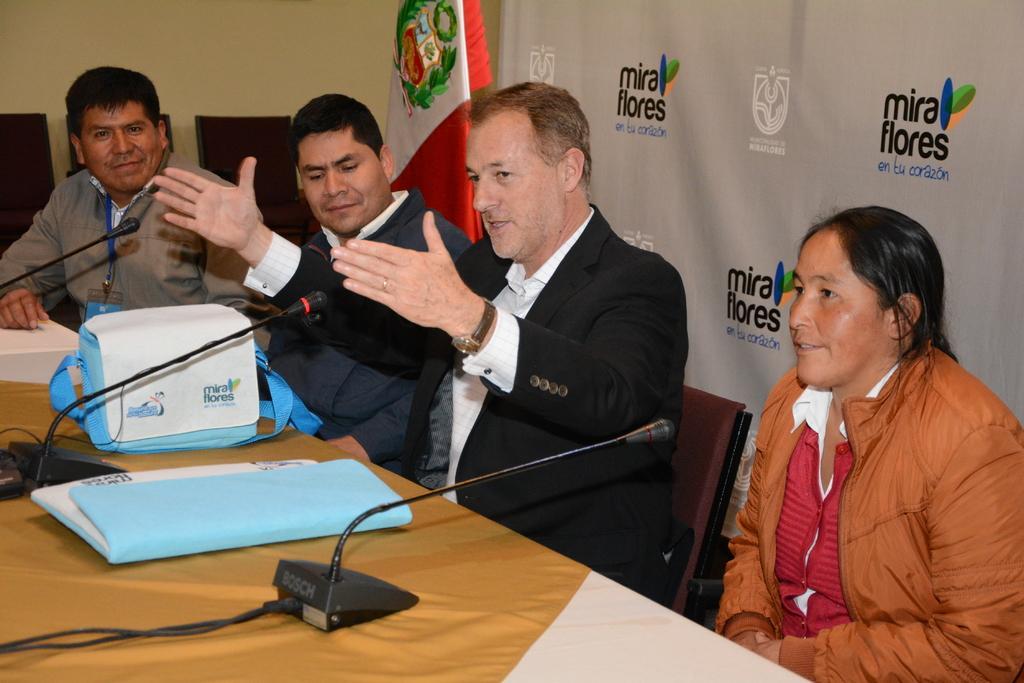How would you summarize this image in a sentence or two? This picture describes about group of people, they are seated on the chairs, in front of them we can find few microphones, bag and a file on the table,, in the background we can see a flag and a hoarding. 